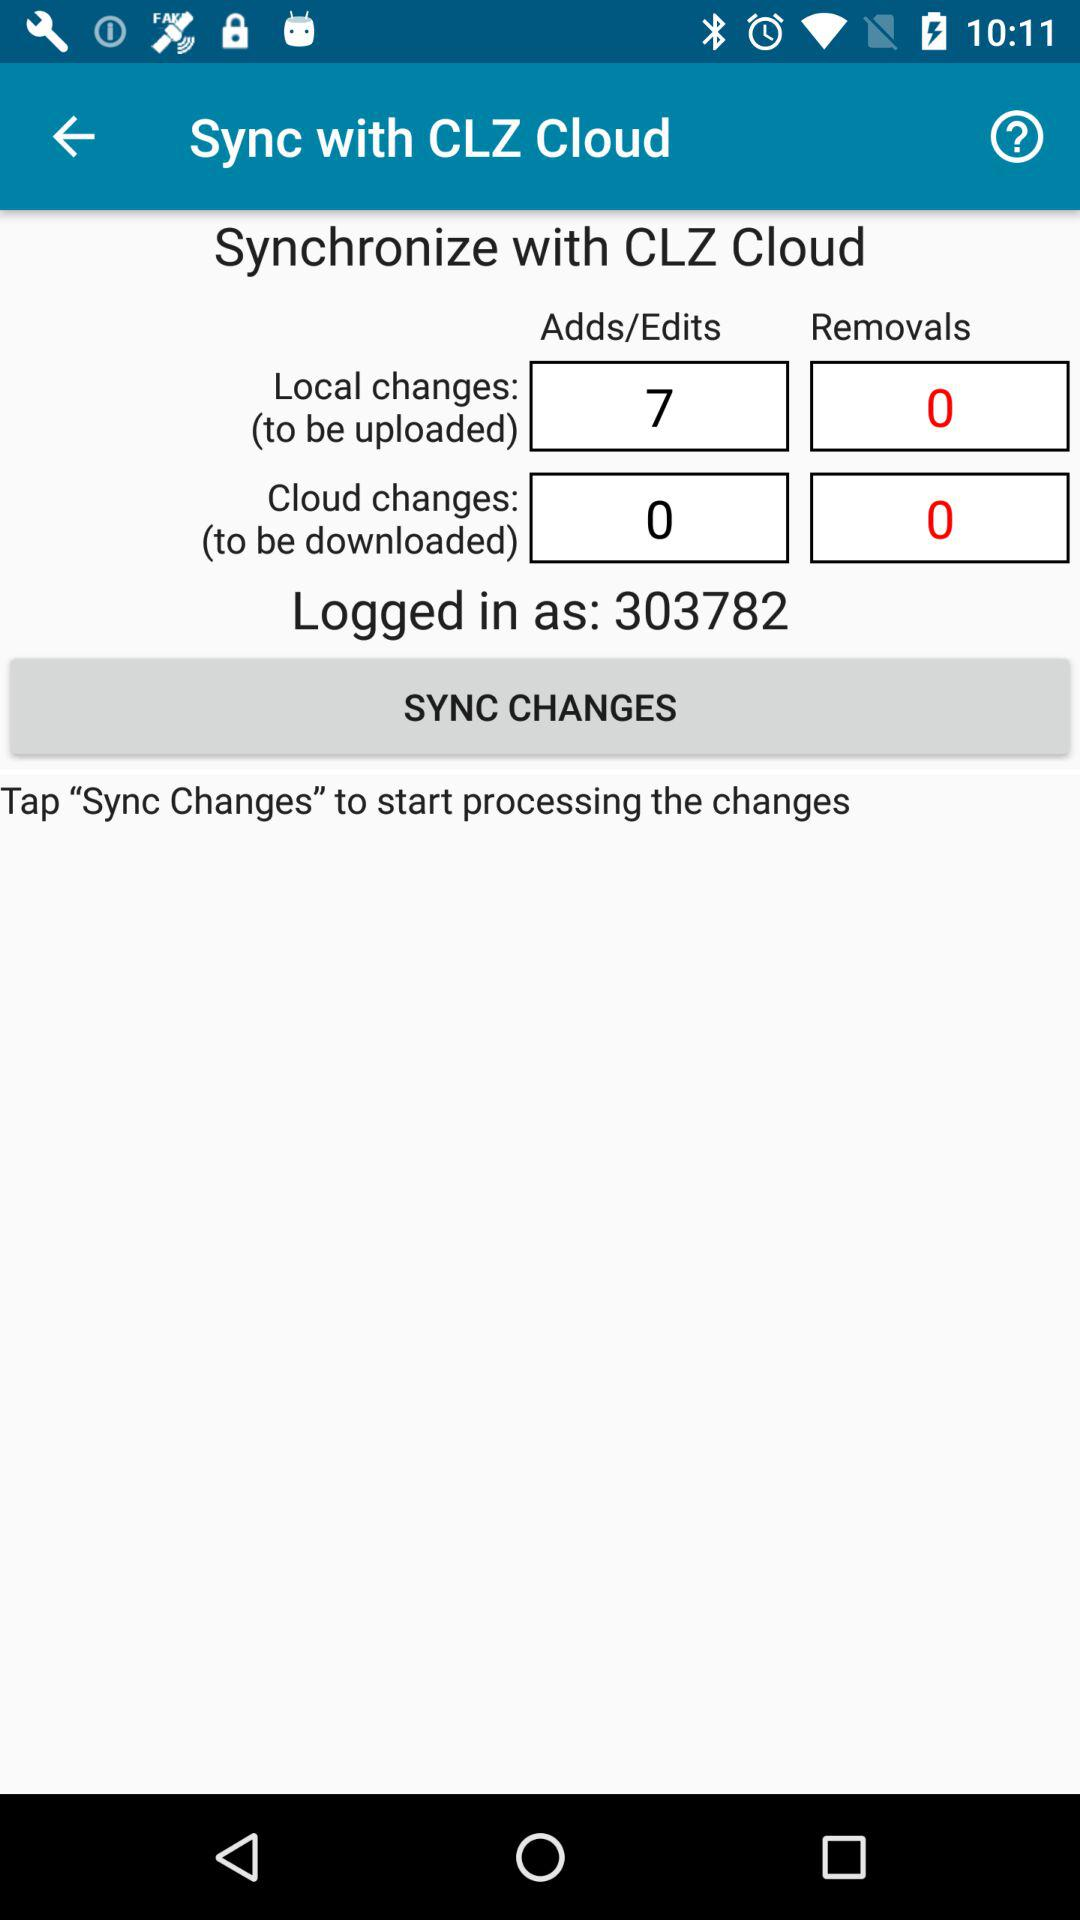How many more additions and edits are there than removals? 7 